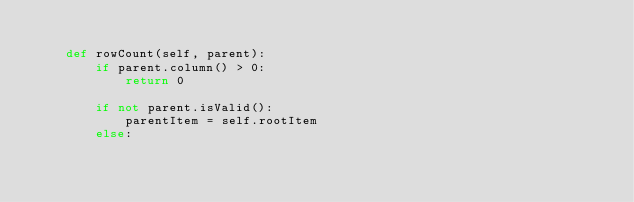<code> <loc_0><loc_0><loc_500><loc_500><_Python_>
    def rowCount(self, parent):
        if parent.column() > 0:
            return 0

        if not parent.isValid():
            parentItem = self.rootItem
        else:</code> 